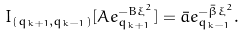Convert formula to latex. <formula><loc_0><loc_0><loc_500><loc_500>I _ { ( q _ { k + 1 } , { q _ { k - 1 } } ) } [ A e _ { q _ { k + 1 } } ^ { - B \xi ^ { 2 } } ] = \bar { a } e _ { q _ { k - 1 } } ^ { - \bar { \beta } \xi ^ { 2 } } .</formula> 